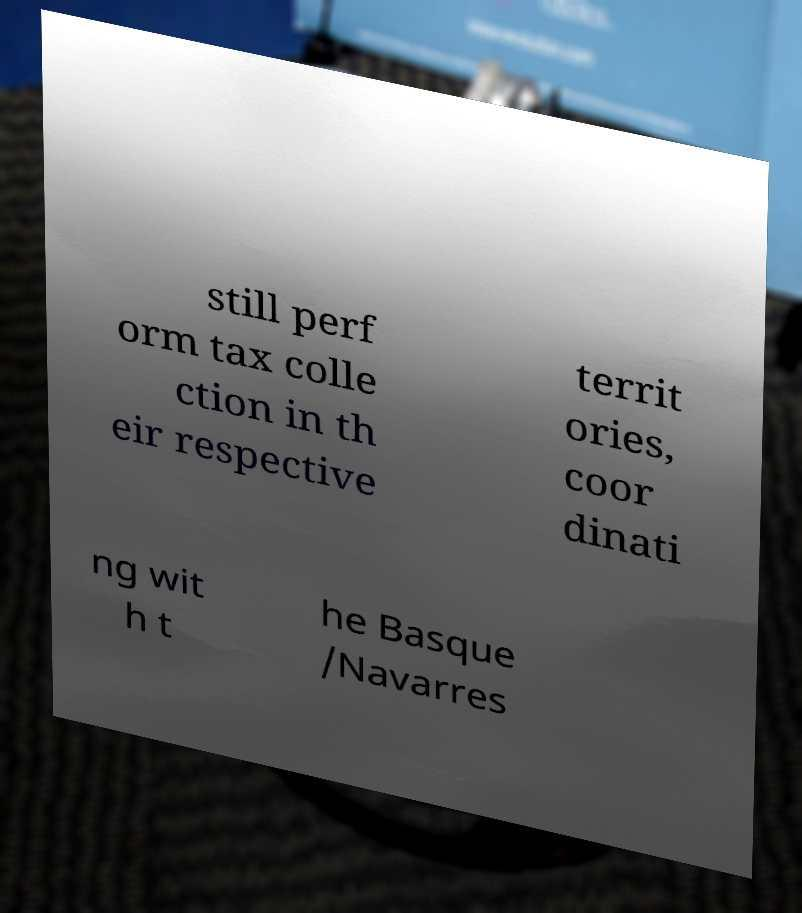For documentation purposes, I need the text within this image transcribed. Could you provide that? still perf orm tax colle ction in th eir respective territ ories, coor dinati ng wit h t he Basque /Navarres 